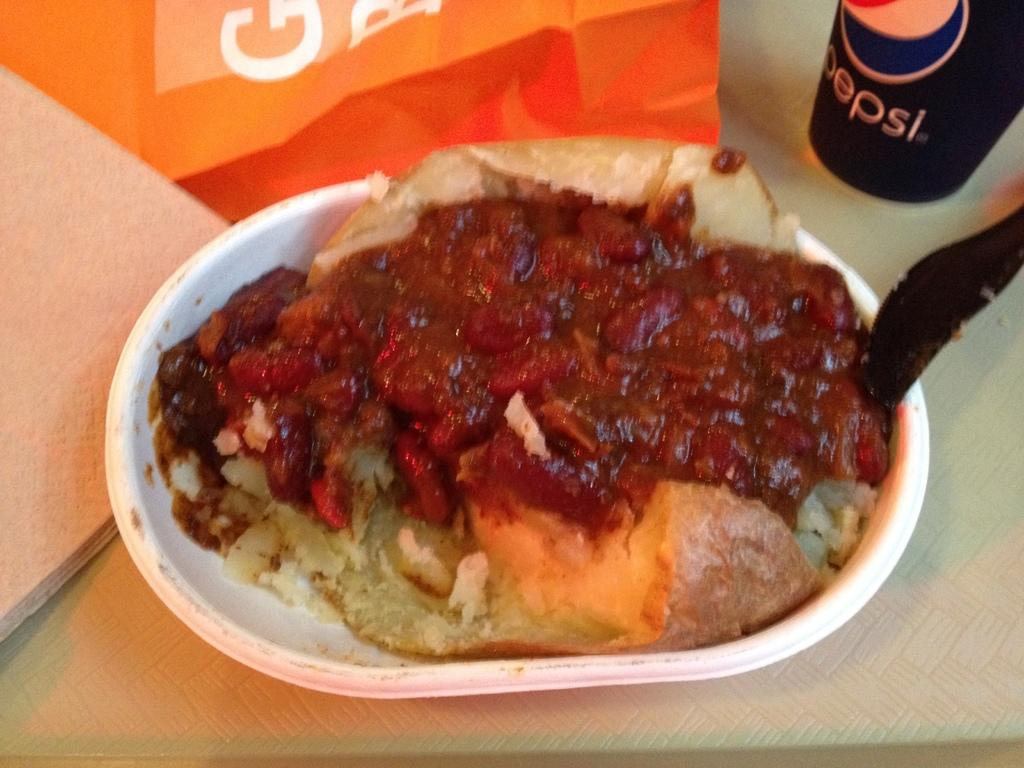What is on the plate in the image? There is food on a plate in the image. What utensil is on the plate with the food? There is a spoon on the plate. What can be seen in the background of the image? In the background, there are tissues and paper. What is on the table in the image besides the plate? There is a bottle on the table in the image. What is the limit of the thing causing the paper to move in the image? There is no thing causing the paper to move in the image, and therefore no limit can be determined. 